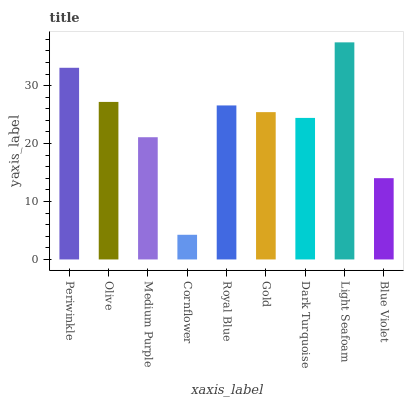Is Olive the minimum?
Answer yes or no. No. Is Olive the maximum?
Answer yes or no. No. Is Periwinkle greater than Olive?
Answer yes or no. Yes. Is Olive less than Periwinkle?
Answer yes or no. Yes. Is Olive greater than Periwinkle?
Answer yes or no. No. Is Periwinkle less than Olive?
Answer yes or no. No. Is Gold the high median?
Answer yes or no. Yes. Is Gold the low median?
Answer yes or no. Yes. Is Light Seafoam the high median?
Answer yes or no. No. Is Light Seafoam the low median?
Answer yes or no. No. 